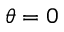<formula> <loc_0><loc_0><loc_500><loc_500>\theta = 0</formula> 